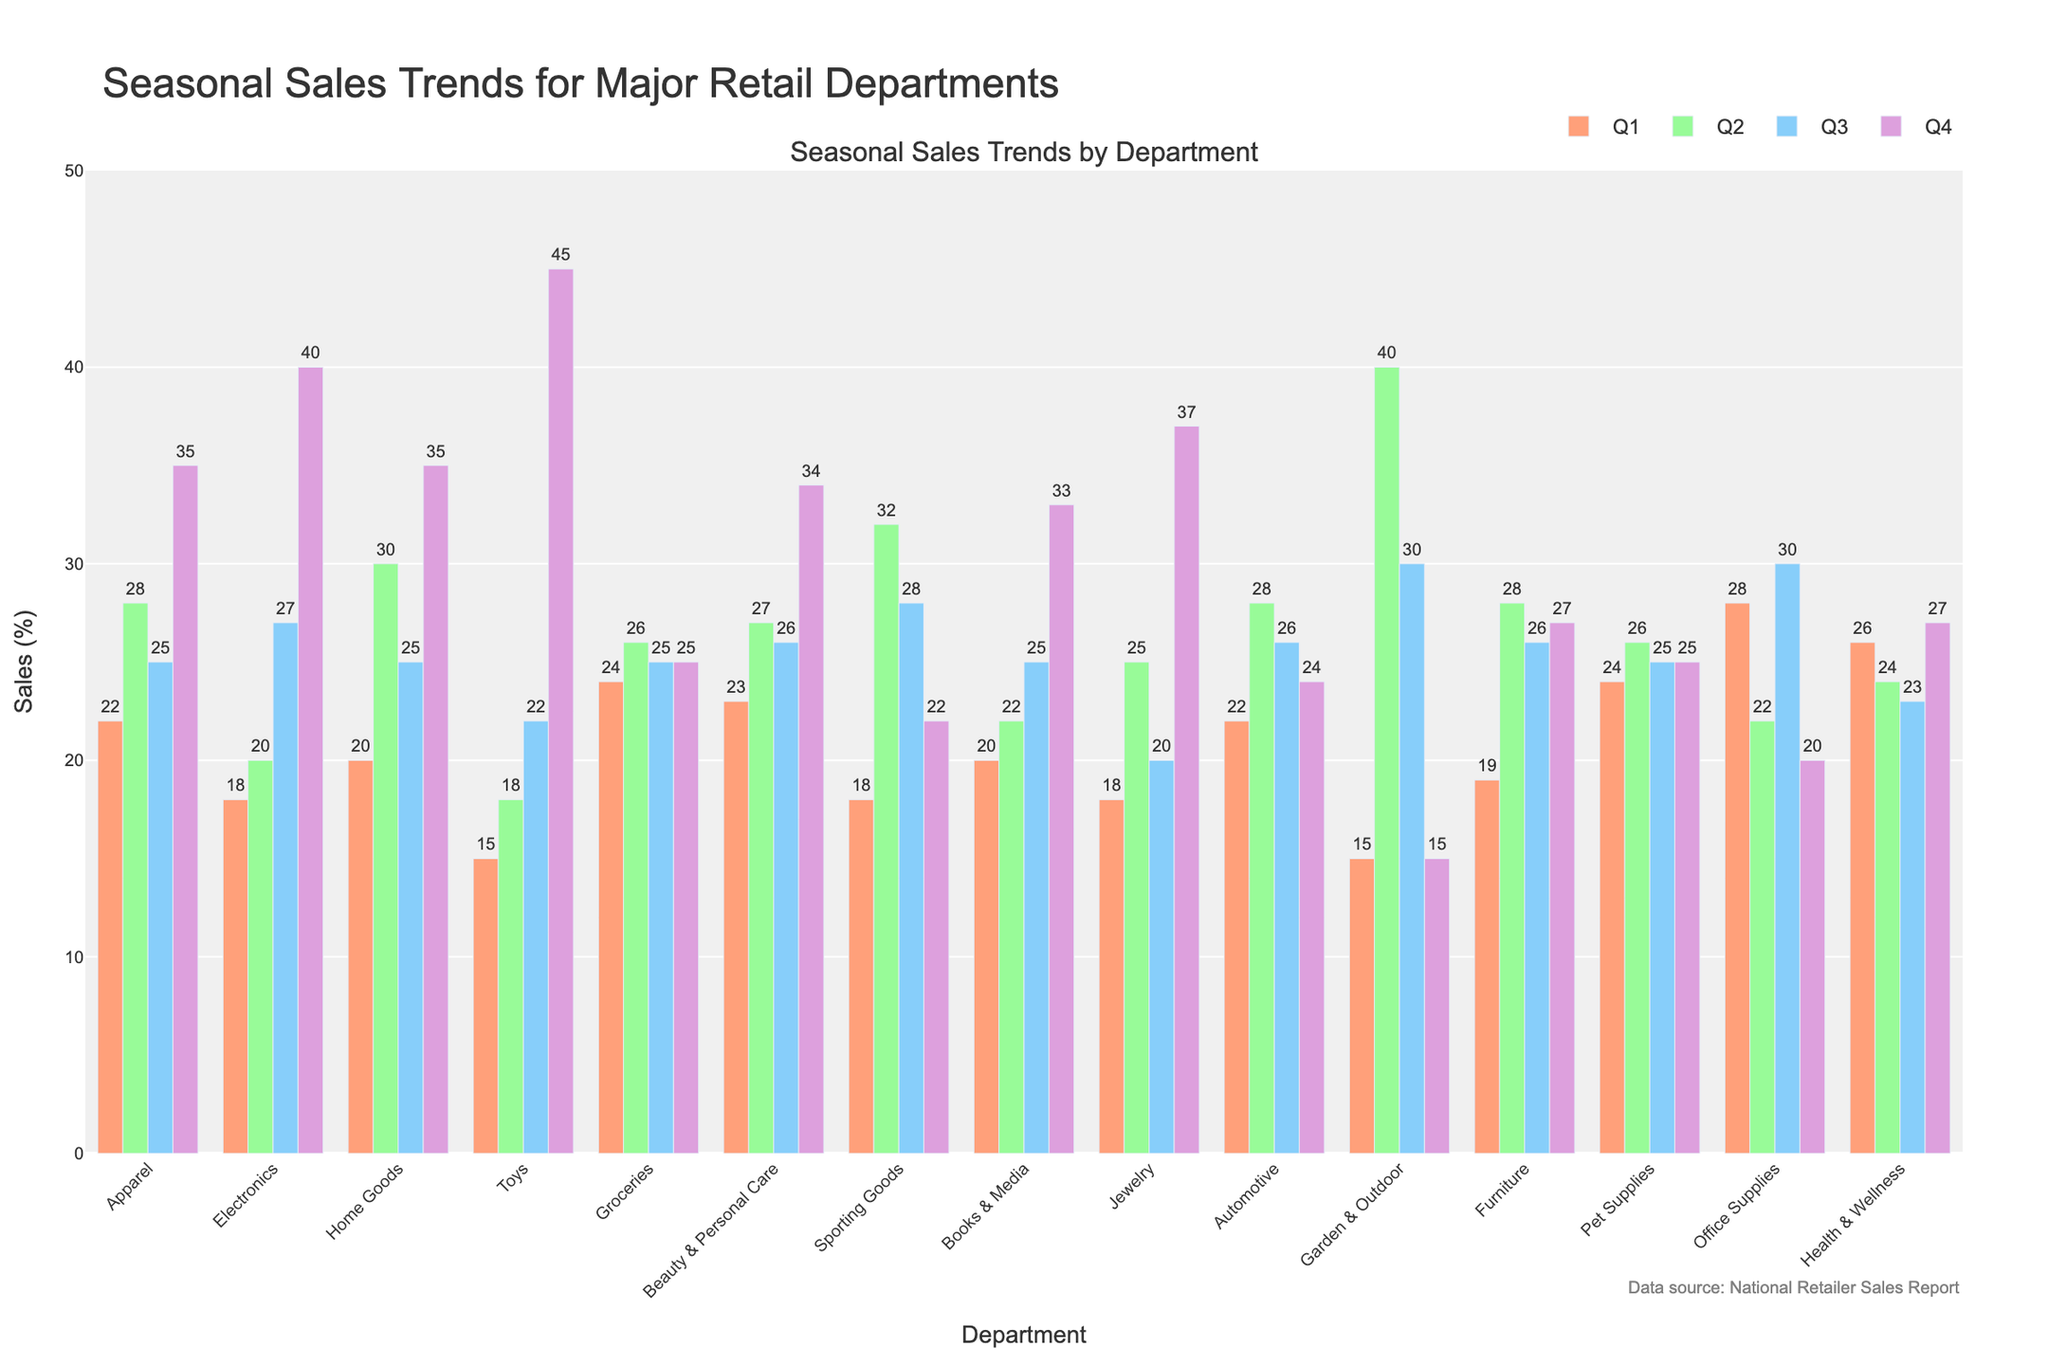What's the highest sales percentage in Q4? In Q4, the highest sales percentage is represented by the tallest bar, which is for the Toys department.
Answer: 45 Which department has the lowest sales in Q1? The lowest sales in Q1 are represented by the shortest bar, which is for the Toys and Garden & Outdoor departments.
Answer: Toys and Garden & Outdoor How much do Automotive sales change from Q3 to Q4? Automotive sales in Q3 are 26, and in Q4, they are 24. The change is calculated as 24 - 26, which is a decrease of 2.
Answer: -2 What is the average sales percentage for Home Goods across all quarters? The sales percentages for Home Goods are 20 (Q1), 30 (Q2), 25 (Q3), and 35 (Q4). The average is calculated as (20 + 30 + 25 + 35) / 4 = 27.5.
Answer: 27.5 Which quarter shows the largest sales increase for Electronics? The sales for Electronics are 18 in Q1, 20 in Q2, 27 in Q3, and 40 in Q4. The largest increase is from Q3 to Q4 (27 to 40), an increase of 13.
Answer: Q4 Which two departments have the most similar sales trends in Q2? In Q2, the sales for Apparel and Automotive are both 28, indicating similar sales trends.
Answer: Apparel and Automotive What is the total sales percentage for Beauty & Personal Care for the entire year? The sales percentages for Beauty & Personal Care are 23 (Q1), 27 (Q2), 26 (Q3), and 34 (Q4). Summing these gives 23 + 27 + 26 + 34 = 110.
Answer: 110 In which quarter does Office Supplies experience the highest sales? The highest sales for Office Supplies occur in Q3, represented by the tallest bar at 30.
Answer: Q3 Comparing Q3, which department shows the largest sales percentage difference? In Q3, the largest difference is between the sales of Toys (22) and Sporting Goods (28). The difference is calculated as 28 - 22 = 6.
Answer: Toys and Sporting Goods 